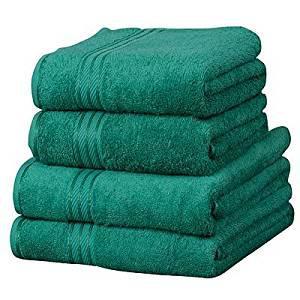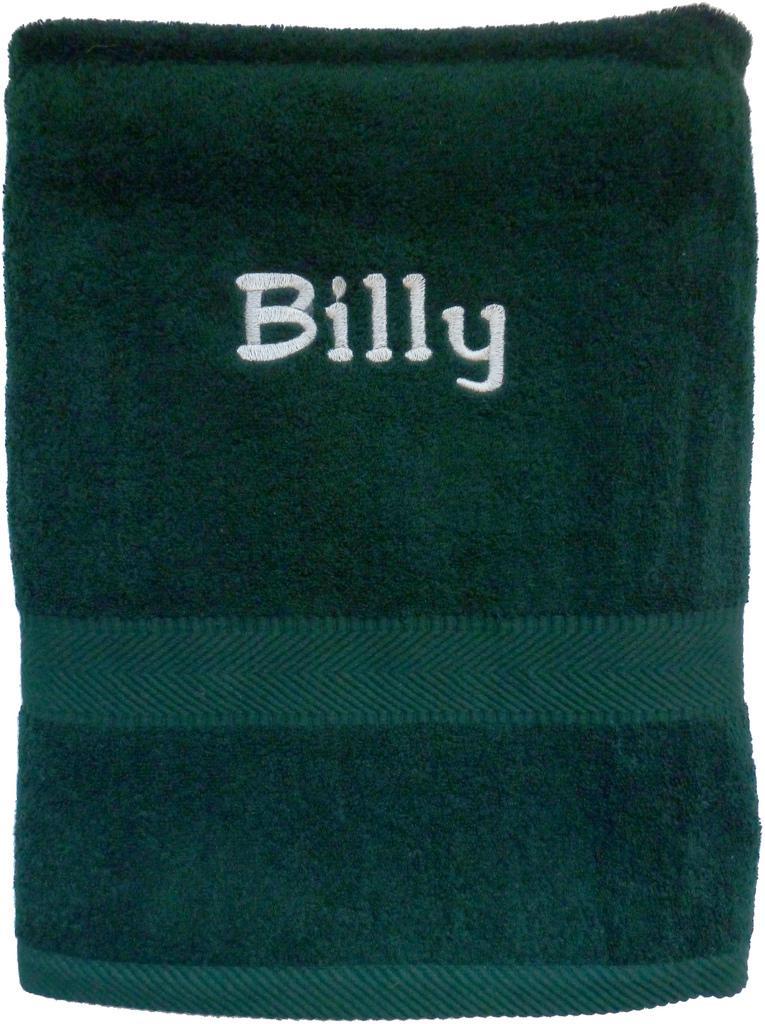The first image is the image on the left, the second image is the image on the right. For the images displayed, is the sentence "In one image there are six green towels." factually correct? Answer yes or no. No. The first image is the image on the left, the second image is the image on the right. Examine the images to the left and right. Is the description "There are exactly six towels in the right image." accurate? Answer yes or no. No. 